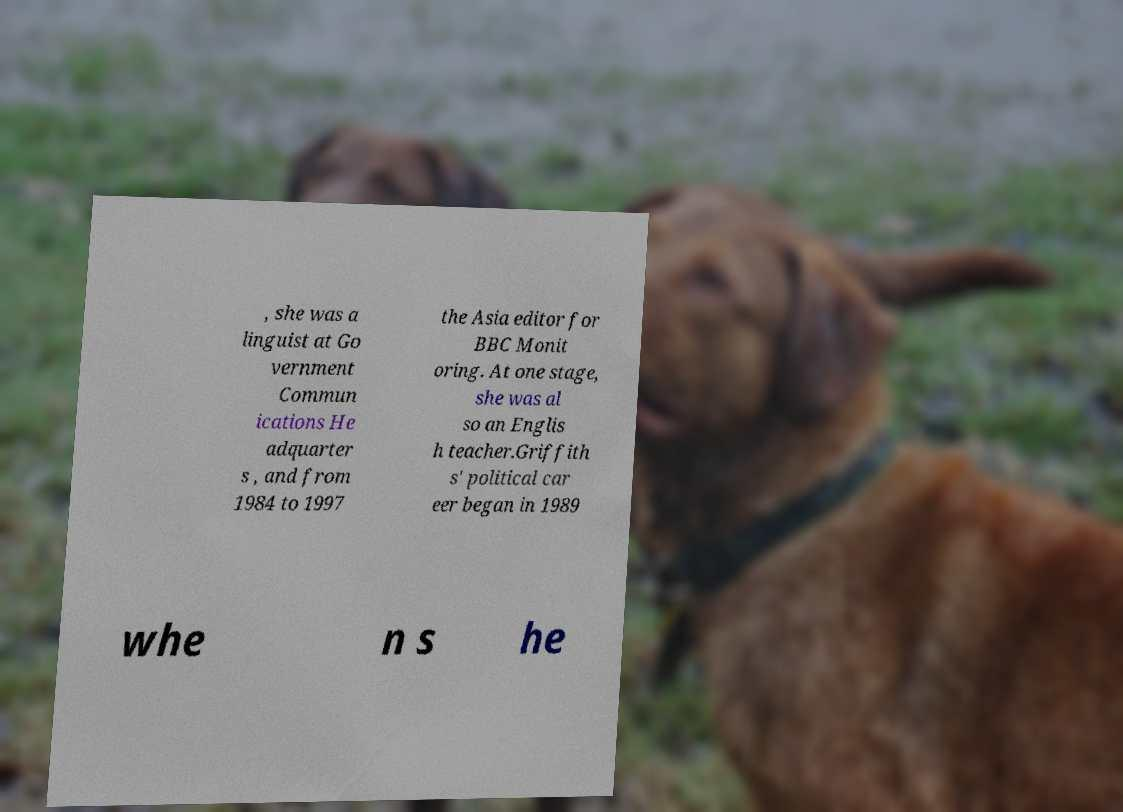Can you read and provide the text displayed in the image?This photo seems to have some interesting text. Can you extract and type it out for me? , she was a linguist at Go vernment Commun ications He adquarter s , and from 1984 to 1997 the Asia editor for BBC Monit oring. At one stage, she was al so an Englis h teacher.Griffith s' political car eer began in 1989 whe n s he 